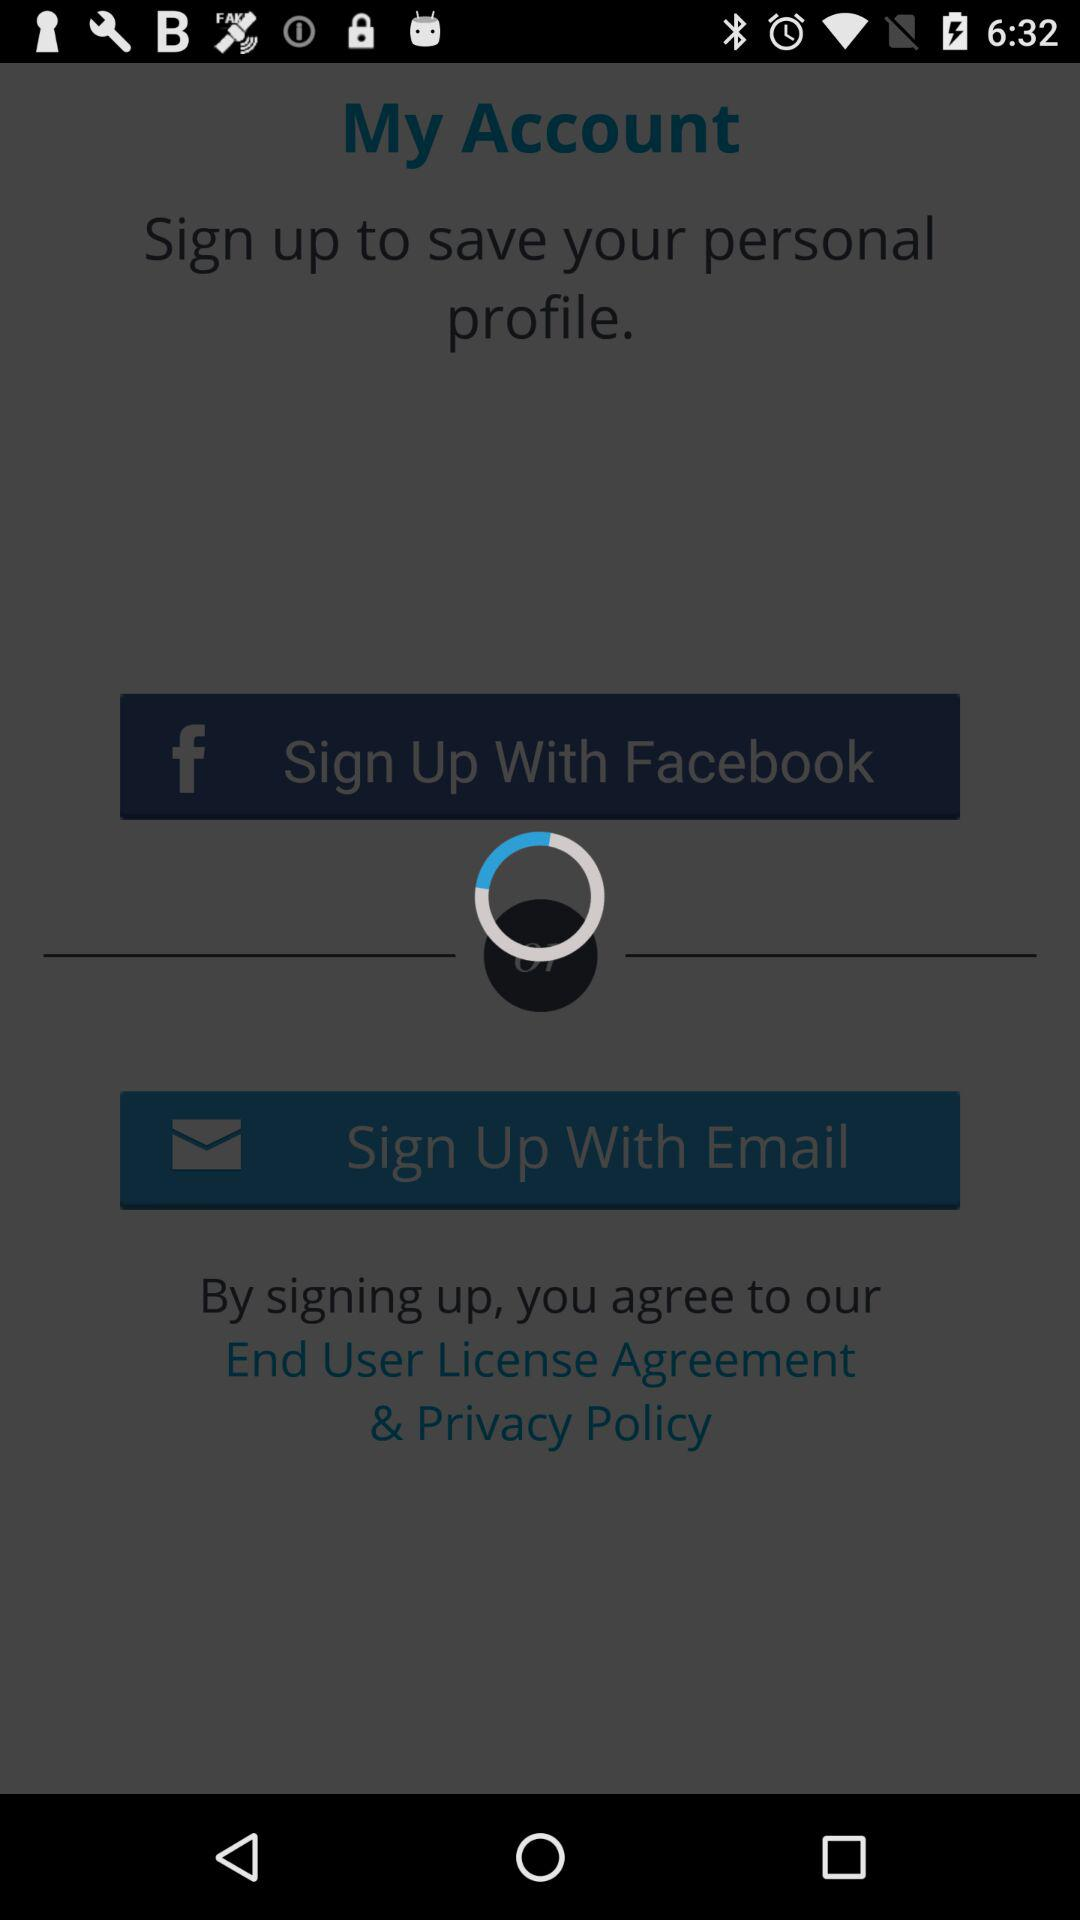What other applications can use the profile to sign up? The application that can use the profile to sign up is "Facebook". 